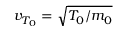Convert formula to latex. <formula><loc_0><loc_0><loc_500><loc_500>v _ { T _ { 0 } } = \sqrt { T _ { 0 } / m _ { 0 } }</formula> 